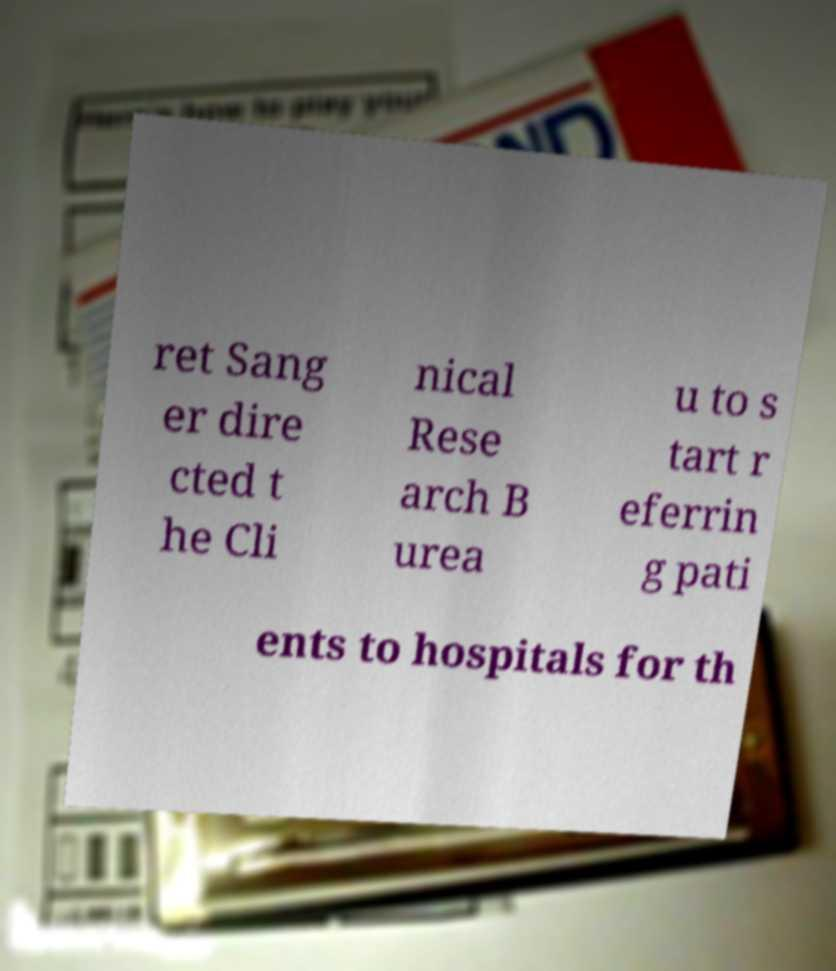What messages or text are displayed in this image? I need them in a readable, typed format. ret Sang er dire cted t he Cli nical Rese arch B urea u to s tart r eferrin g pati ents to hospitals for th 